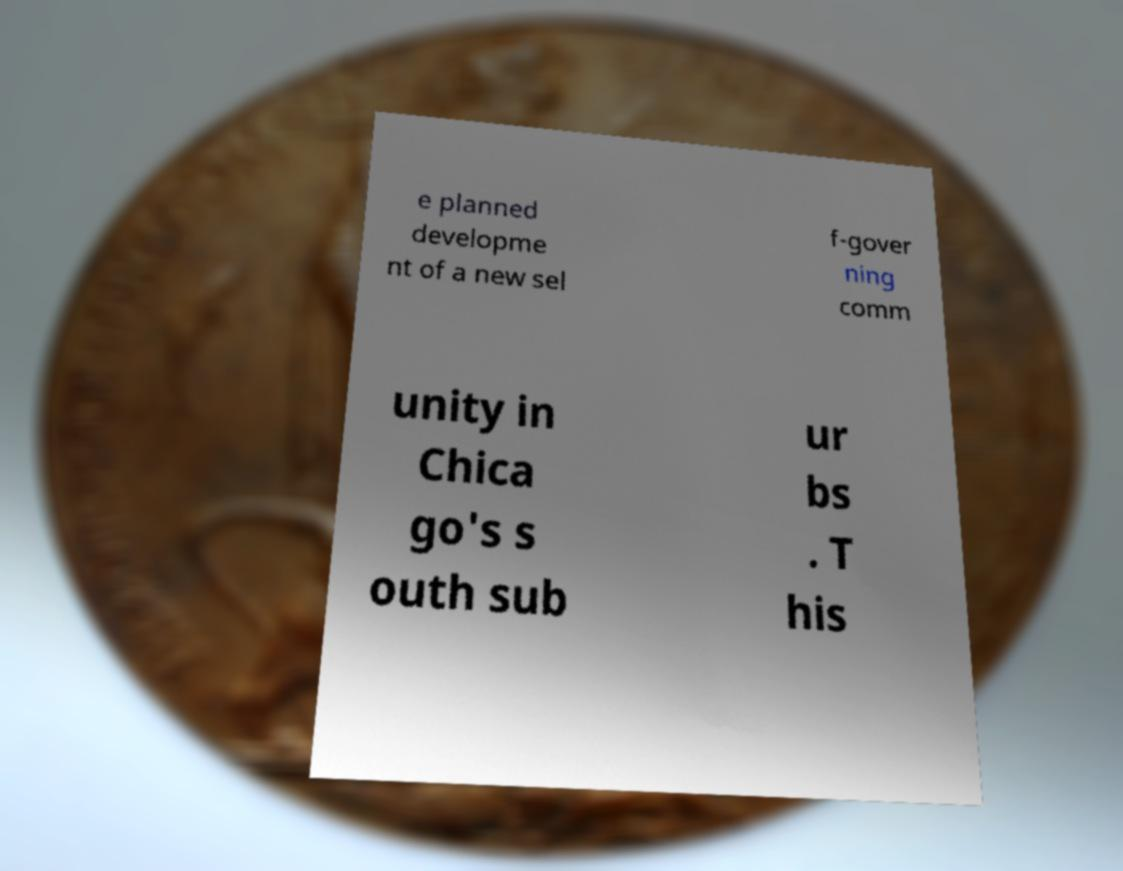What messages or text are displayed in this image? I need them in a readable, typed format. e planned developme nt of a new sel f-gover ning comm unity in Chica go's s outh sub ur bs . T his 